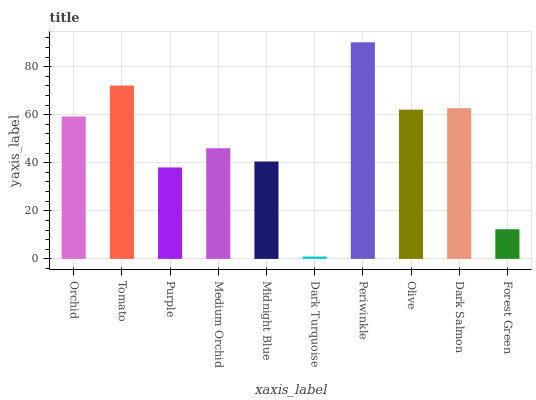Is Dark Turquoise the minimum?
Answer yes or no. Yes. Is Periwinkle the maximum?
Answer yes or no. Yes. Is Tomato the minimum?
Answer yes or no. No. Is Tomato the maximum?
Answer yes or no. No. Is Tomato greater than Orchid?
Answer yes or no. Yes. Is Orchid less than Tomato?
Answer yes or no. Yes. Is Orchid greater than Tomato?
Answer yes or no. No. Is Tomato less than Orchid?
Answer yes or no. No. Is Orchid the high median?
Answer yes or no. Yes. Is Medium Orchid the low median?
Answer yes or no. Yes. Is Medium Orchid the high median?
Answer yes or no. No. Is Purple the low median?
Answer yes or no. No. 